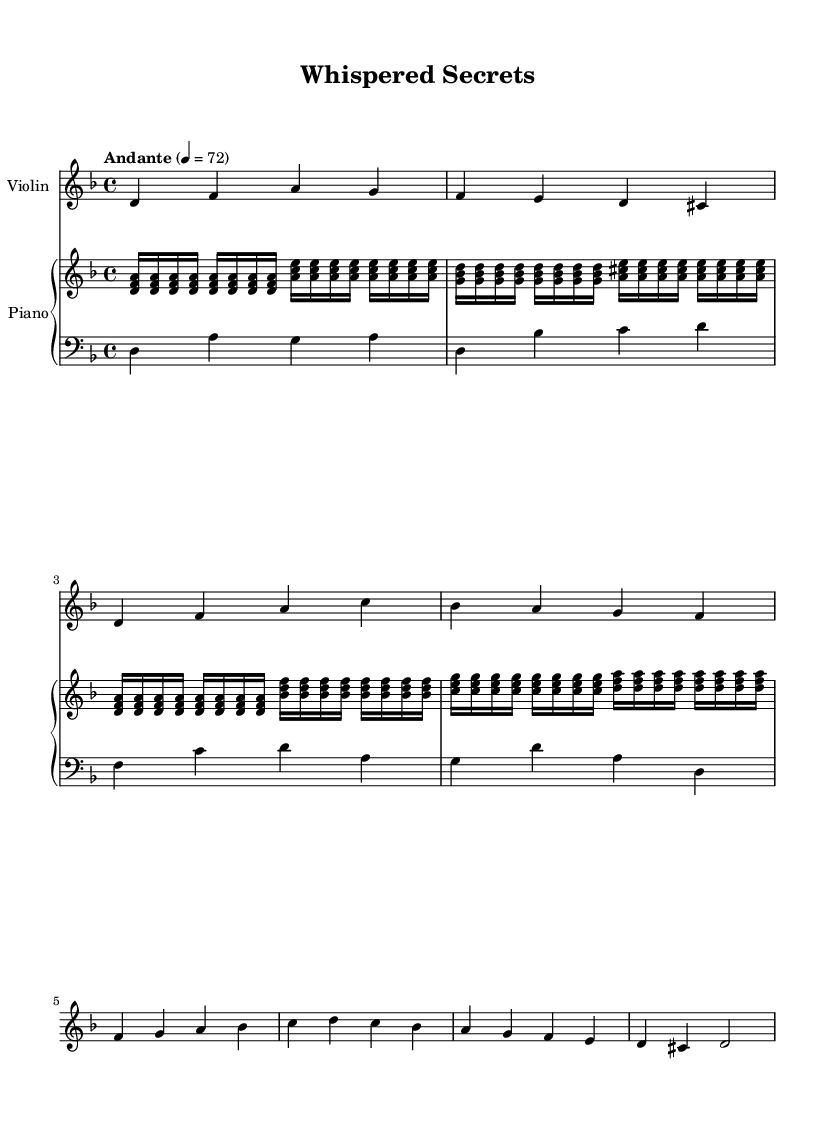What is the key signature of this music? The key signature can be identified by looking at the beginning of the staff. Here, it shows a key of D minor, which has one flat (B flat).
Answer: D minor What is the time signature? The time signature is found next to the key signature at the beginning of the piece; it indicates how many beats are in each measure. Here, the time signature is 4/4, which means there are four beats per measure.
Answer: 4/4 What is the indicated tempo of this piece? The tempo marking, found above the staff, describes the speed of the music. In this case, it states "Andante" with a metronome marking of 72, which indicates a moderately slow pace.
Answer: Andante 4 = 72 How many measures are in the violin part? To determine the number of measures in the violin part, we count the distinct groups of notes separated by vertical lines (bar lines) in the violin notation. There are eight measures present in the violin part.
Answer: 8 Which instrument appears with the upper staff in the piano? The upper staff in the piano part is designated for the treble voice, which in this case is labeled "upper." This identifies it as the part for the piano; thus, the instrument on the upper staff is the piano.
Answer: Piano What type of harmony can be heard in the piano part? The piano part features a mix of arpeggiated chords and sustained notes. This harmonic texture contributes to the ambient quality typical of electronic-classical fusion music, where the piano often creates a lush, atmospheric backdrop for the solo violin.
Answer: Ambient What mood is suggested by the music? The music has an introspective and tranquil quality, which is characteristic of ambient electronic-classical fusion. The minor key combined with the flowing melodies and harmonies creates a reflective mood suitable for late-night library sessions.
Answer: Reflective 